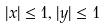<formula> <loc_0><loc_0><loc_500><loc_500>| x | \leq 1 , | y | \leq 1</formula> 